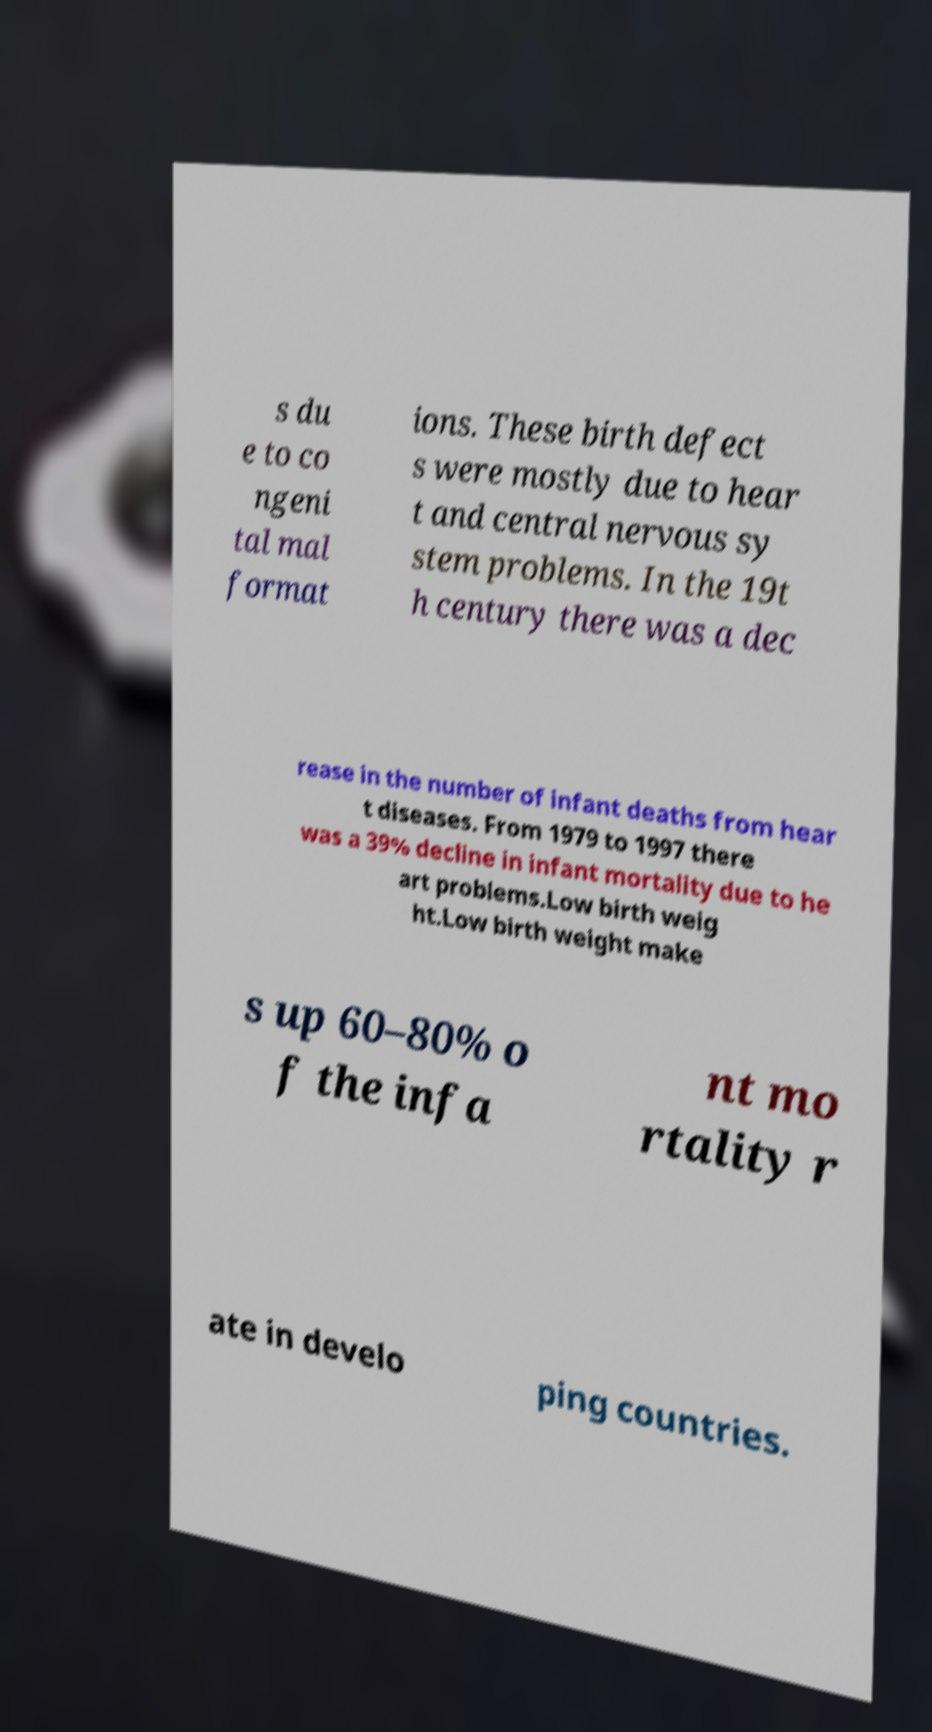Could you extract and type out the text from this image? s du e to co ngeni tal mal format ions. These birth defect s were mostly due to hear t and central nervous sy stem problems. In the 19t h century there was a dec rease in the number of infant deaths from hear t diseases. From 1979 to 1997 there was a 39% decline in infant mortality due to he art problems.Low birth weig ht.Low birth weight make s up 60–80% o f the infa nt mo rtality r ate in develo ping countries. 